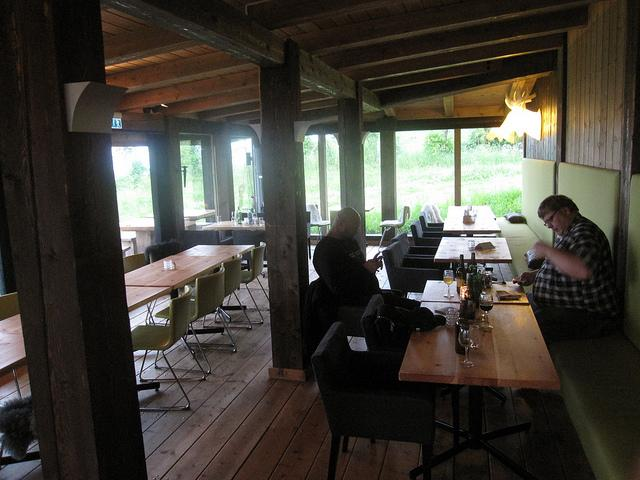What kind of shirt is the heavier man wearing?

Choices:
A) none
B) red
C) checkered
D) long sleeve checkered 